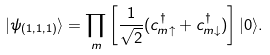<formula> <loc_0><loc_0><loc_500><loc_500>| \psi _ { ( 1 , 1 , 1 ) } \rangle = \prod _ { m } \left [ \frac { 1 } { \sqrt { 2 } } ( c ^ { \dagger } _ { m \uparrow } + c ^ { \dagger } _ { m \downarrow } ) \right ] | 0 \rangle .</formula> 